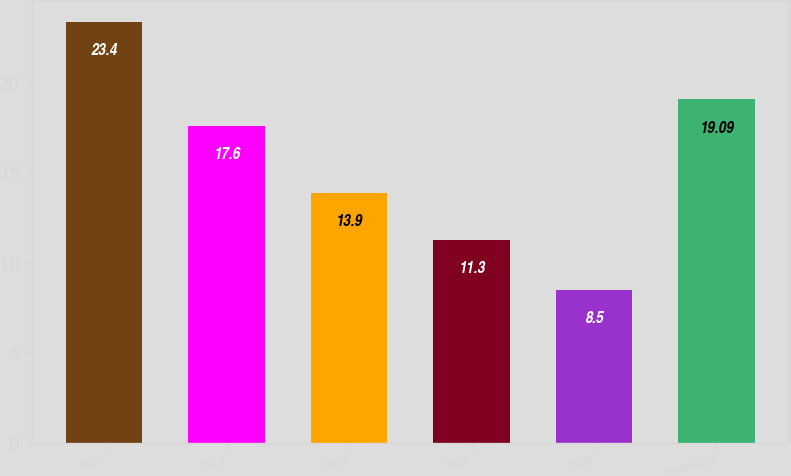<chart> <loc_0><loc_0><loc_500><loc_500><bar_chart><fcel>2015<fcel>2016<fcel>2017<fcel>2018<fcel>2019<fcel>Thereafter<nl><fcel>23.4<fcel>17.6<fcel>13.9<fcel>11.3<fcel>8.5<fcel>19.09<nl></chart> 